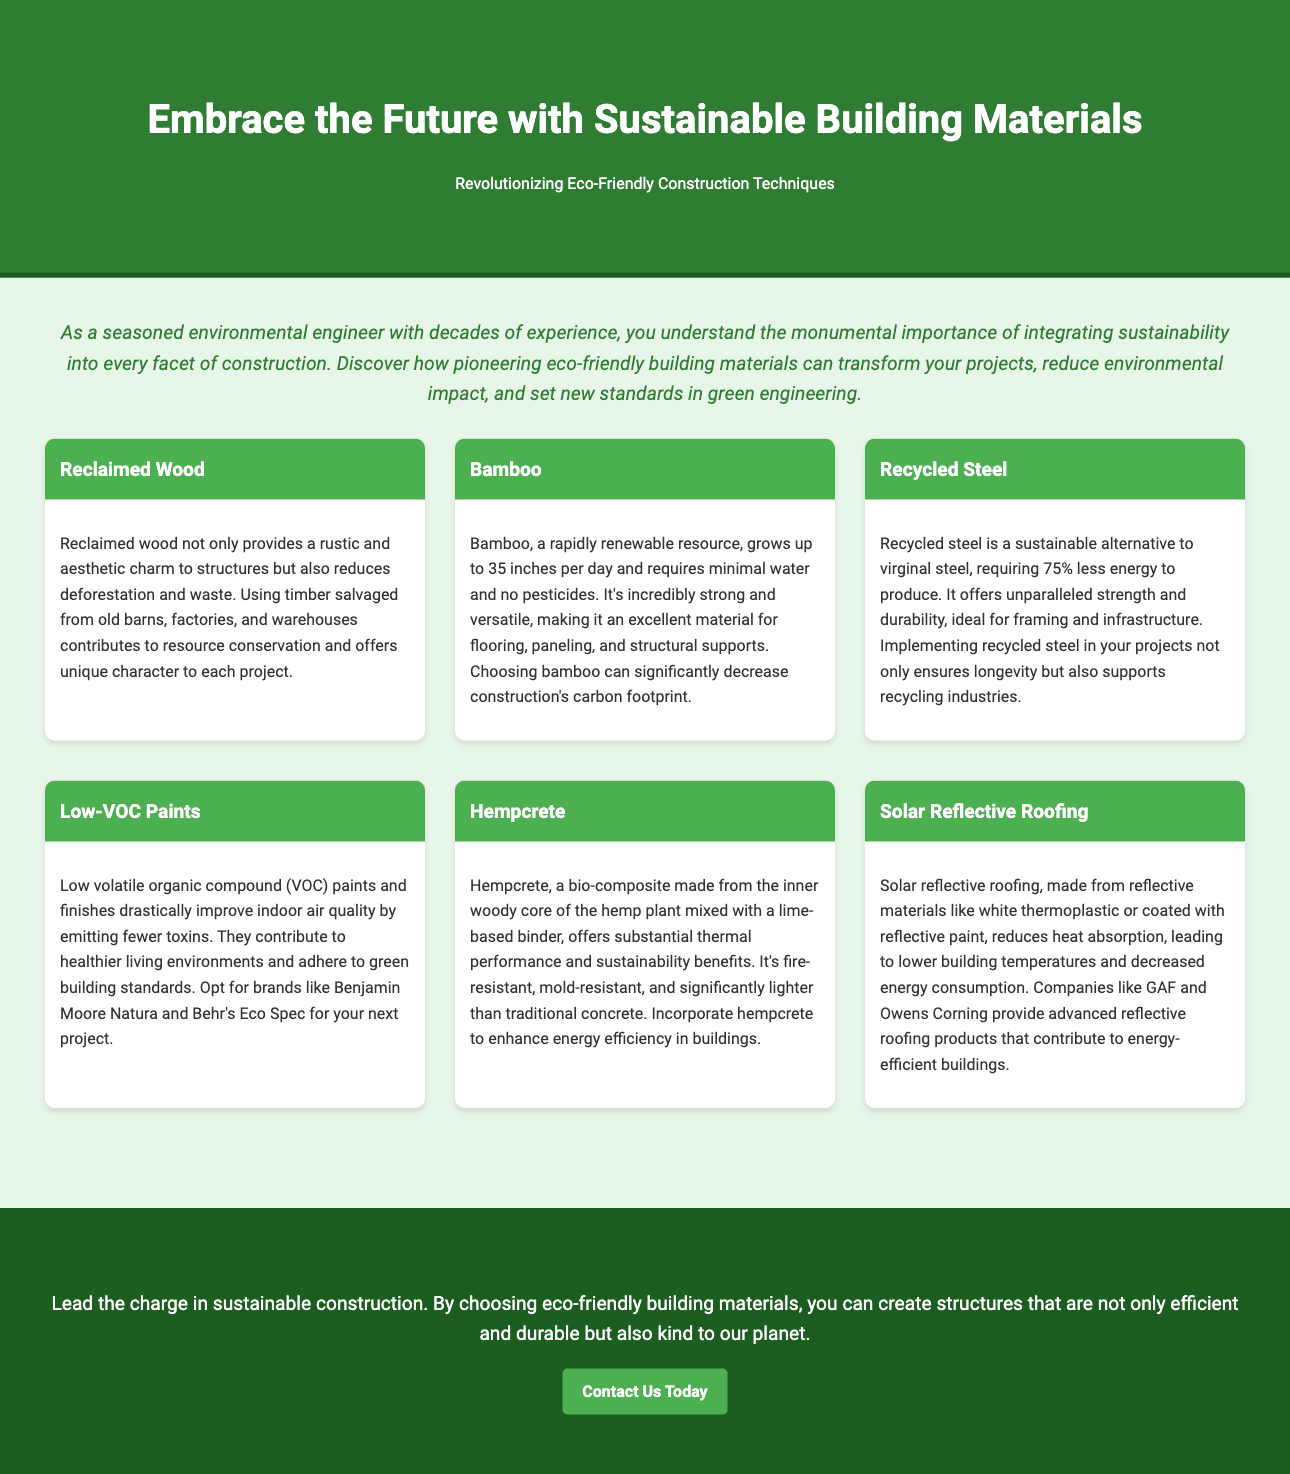what is the title of the advertisement? The title of the advertisement is found in the header section, which presents the main theme of the document.
Answer: Embrace the Future with Sustainable Building Materials what is the main focus of this advertisement? The focus is encapsulated in the subtitle under the title, summarizing the central theme of eco-friendliness in construction.
Answer: Revolutionizing Eco-Friendly Construction Techniques how many sustainable materials are listed in the document? The number of materials is indicated through the individual sections dedicated to each type of material under the materials section.
Answer: Six which material is noted for being a rapidly renewable resource? This information is specified in the section dedicated to the specific material, highlighting its growth rate and sustainability.
Answer: Bamboo what is the advantage of using recycled steel? The advantage is outlined in the material's section, emphasizing energy efficiency and durability compared to traditional steel.
Answer: Requires 75% less energy to produce what does Hempcrete enhance according to the advertisement? The enhancement is mentioned within the description of Hempcrete, focusing on its benefits in energy performance.
Answer: Energy efficiency which company is mentioned as a provider of solar reflective roofing? The reference to this company is made in the materials section discussing roofing solutions.
Answer: GAF who is the target audience for this advertisement? The target audience is indicated through the introduction, which speaks directly to professionals in a specific field regarding sustainability.
Answer: Seasoned environmental engineers what action does the advertisement encourage at the end? The action is proposed in the call-to-action section, indicating what the reader should do next after engaging with the advertisement.
Answer: Contact Us Today 